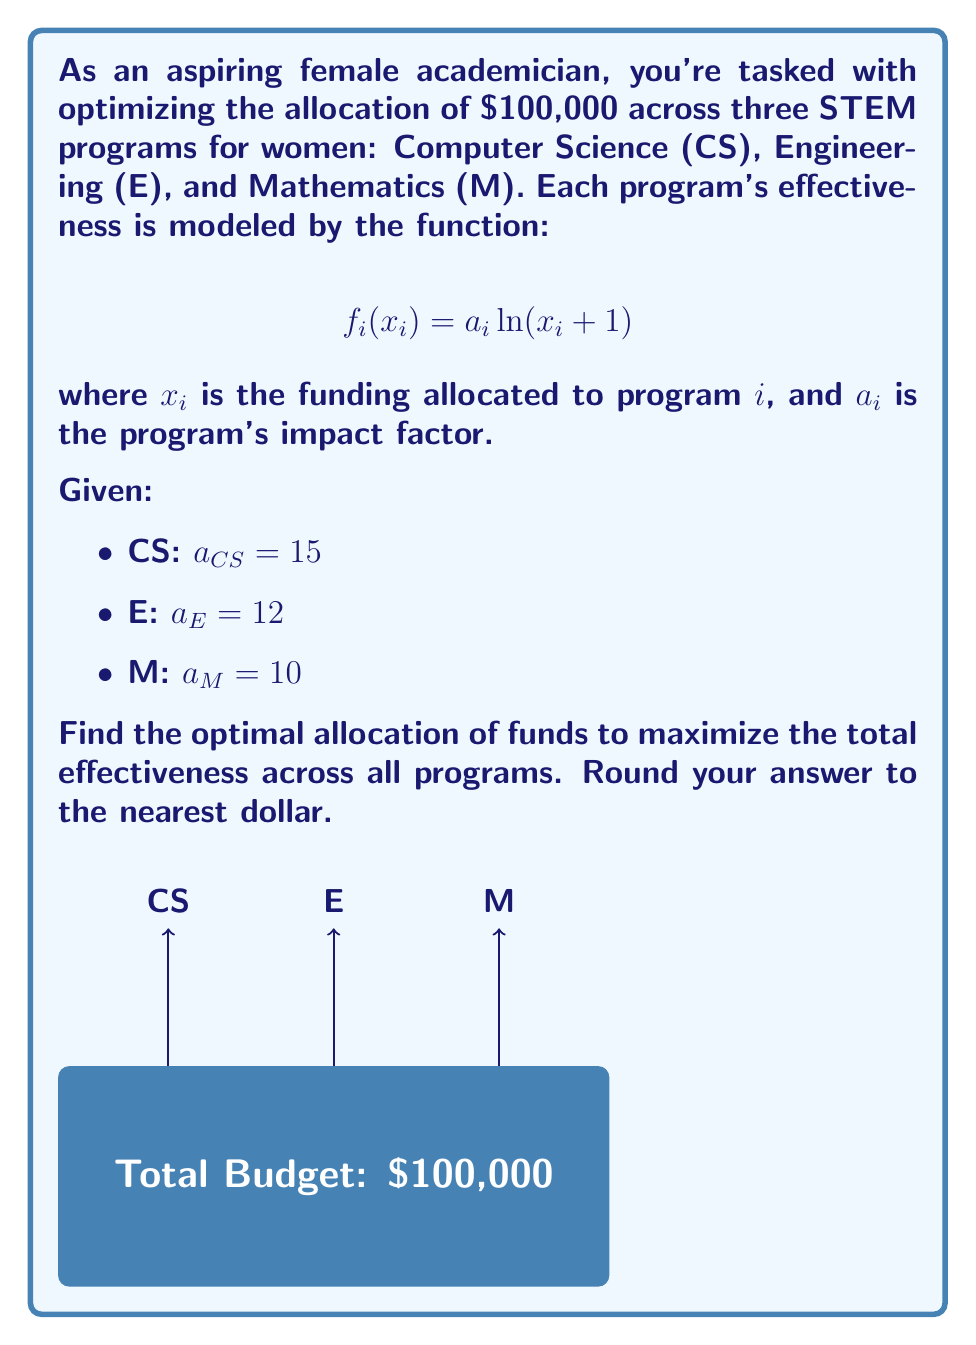Show me your answer to this math problem. To solve this optimization problem, we'll use the method of Lagrange multipliers:

1) Define the objective function:
   $$F(x_{CS}, x_E, x_M) = 15\ln(x_{CS} + 1) + 12\ln(x_E + 1) + 10\ln(x_M + 1)$$

2) Constraint:
   $$x_{CS} + x_E + x_M = 100,000$$

3) Lagrangian function:
   $$L(x_{CS}, x_E, x_M, \lambda) = F(x_{CS}, x_E, x_M) - \lambda(x_{CS} + x_E + x_M - 100,000)$$

4) Partial derivatives:
   $$\frac{\partial L}{\partial x_{CS}} = \frac{15}{x_{CS} + 1} - \lambda = 0$$
   $$\frac{\partial L}{\partial x_E} = \frac{12}{x_E + 1} - \lambda = 0$$
   $$\frac{\partial L}{\partial x_M} = \frac{10}{x_M + 1} - \lambda = 0$$

5) From these equations:
   $$\frac{15}{x_{CS} + 1} = \frac{12}{x_E + 1} = \frac{10}{x_M + 1} = \lambda$$

6) This implies:
   $$x_{CS} + 1 = \frac{15}{\lambda}, x_E + 1 = \frac{12}{\lambda}, x_M + 1 = \frac{10}{\lambda}$$

7) Substituting into the constraint:
   $$(\frac{15}{\lambda} - 1) + (\frac{12}{\lambda} - 1) + (\frac{10}{\lambda} - 1) = 100,000$$
   $$\frac{37}{\lambda} - 3 = 100,000$$
   $$\frac{37}{\lambda} = 100,003$$
   $$\lambda = \frac{37}{100,003} \approx 0.00037$$

8) Solving for $x_{CS}, x_E, x_M$:
   $$x_{CS} = \frac{15}{0.00037} - 1 \approx 40,540$$
   $$x_E = \frac{12}{0.00037} - 1 \approx 32,432$$
   $$x_M = \frac{10}{0.00037} - 1 \approx 27,027$$

9) Rounding to the nearest dollar:
   CS: $40,540
   E: $32,432
   M: $27,028 (adjusted to ensure sum is exactly $100,000)
Answer: CS: $40,540, E: $32,432, M: $27,028 